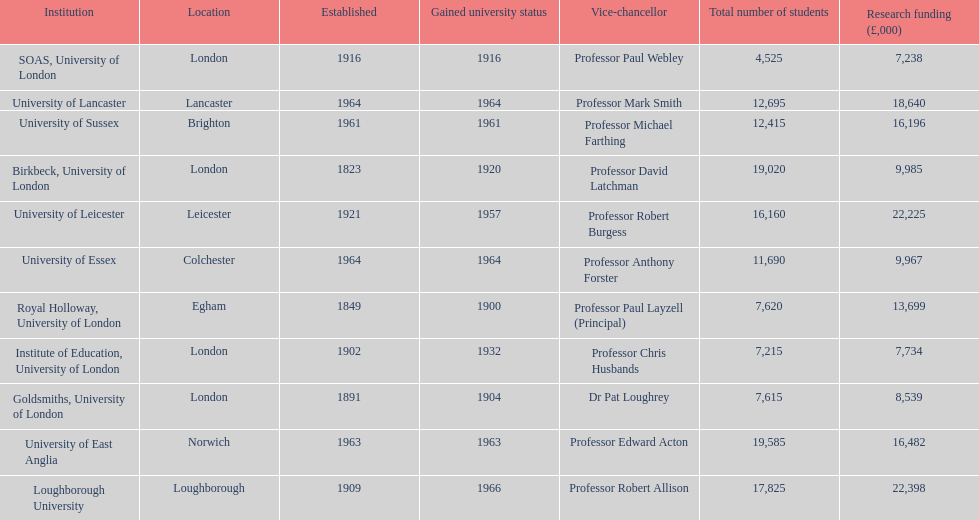What is the most recent institution to gain university status? Loughborough University. 